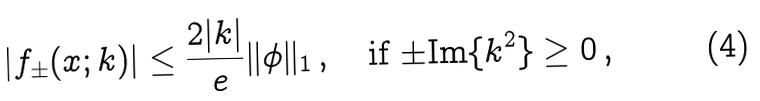Convert formula to latex. <formula><loc_0><loc_0><loc_500><loc_500>| f _ { \pm } ( x ; k ) | \leq \frac { 2 | k | } { \ e } \| \phi \| _ { 1 } \, , \quad \text {if $\pm\text {Im}\{k^{2}\}\geq 0$\,,}</formula> 